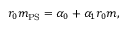Convert formula to latex. <formula><loc_0><loc_0><loc_500><loc_500>r _ { 0 } m _ { P S } = \alpha _ { 0 } + \alpha _ { 1 } r _ { 0 } m ,</formula> 